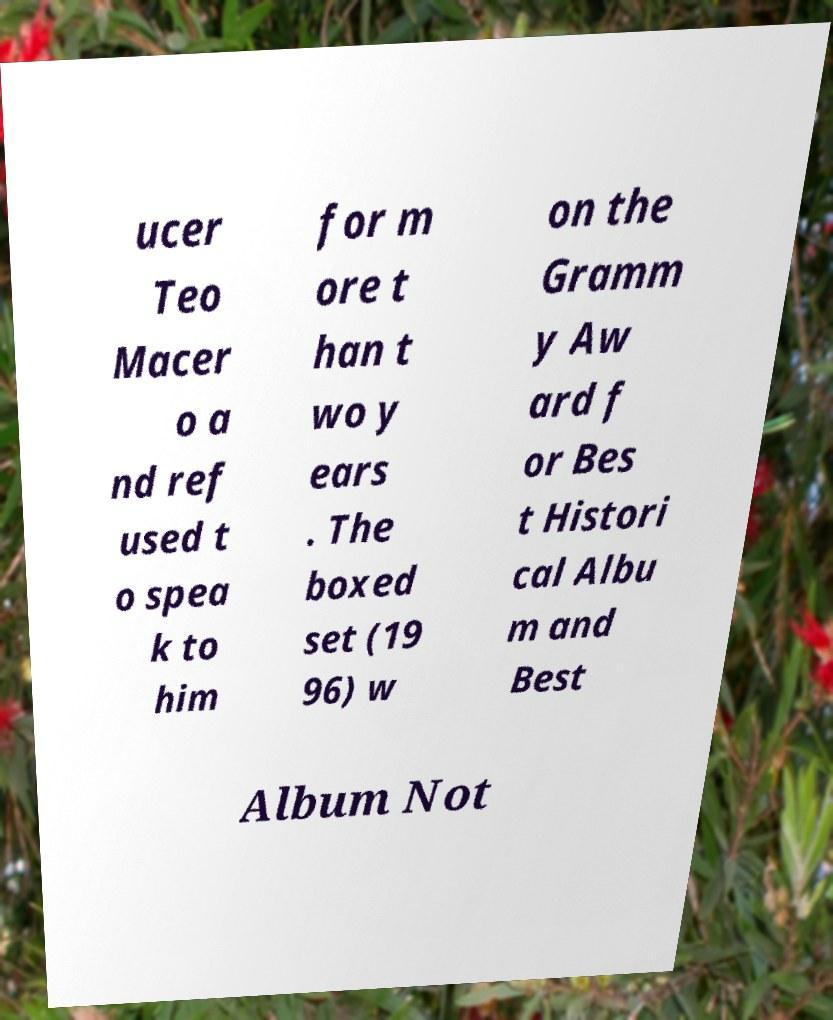Can you accurately transcribe the text from the provided image for me? ucer Teo Macer o a nd ref used t o spea k to him for m ore t han t wo y ears . The boxed set (19 96) w on the Gramm y Aw ard f or Bes t Histori cal Albu m and Best Album Not 